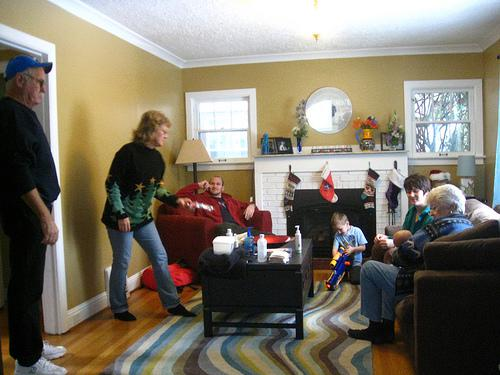Question: where was this photo taken?
Choices:
A. In the mud room.
B. In the bedroom.
C. In a living room.
D. In the study.
Answer with the letter. Answer: C Question: who is present?
Choices:
A. A doctor.
B. People.
C. A fire fighter.
D. A sheriff.
Answer with the letter. Answer: B Question: how is the photo?
Choices:
A. Blurry.
B. Ripped.
C. Clear.
D. Wet.
Answer with the letter. Answer: A Question: why are they talking?
Choices:
A. To preach.
B. To commentate the match.
C. To coach.
D. To converse.
Answer with the letter. Answer: D 